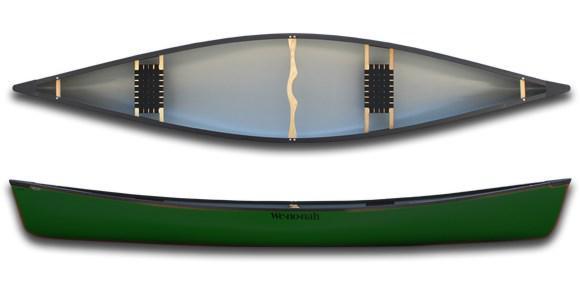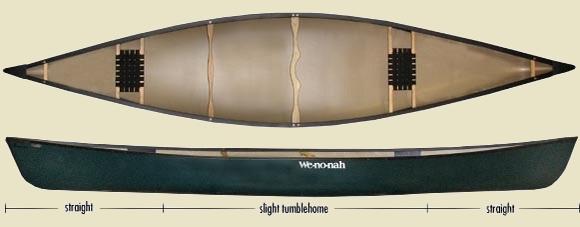The first image is the image on the left, the second image is the image on the right. Analyze the images presented: Is the assertion "Each image features a top-viewed canoe above a side view of a canoe." valid? Answer yes or no. Yes. The first image is the image on the left, the second image is the image on the right. Examine the images to the left and right. Is the description "There is a yellow canoe." accurate? Answer yes or no. No. 